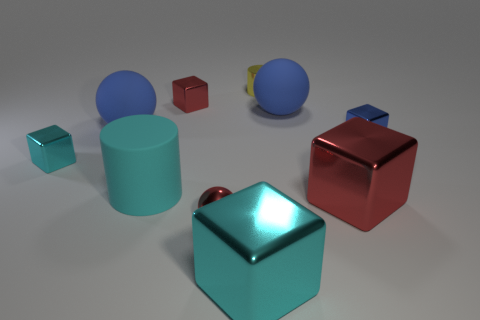There is a tiny thing that is both to the right of the red shiny ball and in front of the tiny yellow shiny thing; what is its shape?
Your response must be concise. Cube. Are there more tiny blue shiny cubes than big cyan objects?
Your answer should be compact. No. What is the tiny cyan block made of?
Make the answer very short. Metal. Are there any other things that are the same size as the blue block?
Provide a short and direct response. Yes. The cyan thing that is the same shape as the small yellow thing is what size?
Provide a succinct answer. Large. There is a small metal block in front of the blue shiny block; is there a shiny cylinder that is on the left side of it?
Give a very brief answer. No. Does the metallic ball have the same color as the metal cylinder?
Make the answer very short. No. How many other things are there of the same shape as the small blue thing?
Offer a very short reply. 4. Is the number of small blue cubes that are in front of the tiny sphere greater than the number of red things that are to the left of the cyan rubber thing?
Your answer should be very brief. No. Is the size of the red metallic cube behind the small blue metallic cube the same as the cylinder that is behind the small cyan block?
Offer a very short reply. Yes. 